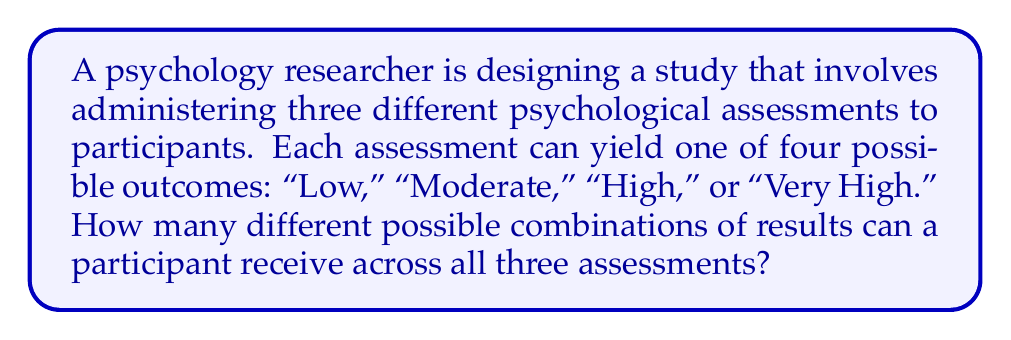Teach me how to tackle this problem. To solve this problem, we need to use the multiplication principle of counting. Here's a step-by-step explanation:

1. Analyze the given information:
   - There are 3 psychological assessments.
   - Each assessment has 4 possible outcomes.

2. For each assessment, the participant can receive one of 4 outcomes. This means we have 4 choices for each assessment.

3. We need to consider the outcomes for all 3 assessments together. Since the outcome of one assessment doesn't affect the others, we multiply the number of choices for each assessment:

   $$\text{Total combinations} = 4 \times 4 \times 4 = 4^3$$

4. Calculate the result:
   $$4^3 = 4 \times 4 \times 4 = 64$$

This calculation gives us the total number of possible combinations of results across all three assessments.

To visualize this, we can think of it as a tree diagram with 4 branches at each of the 3 levels, or as a 3-dimensional grid with 4 options in each dimension.
Answer: 64 possible combinations 